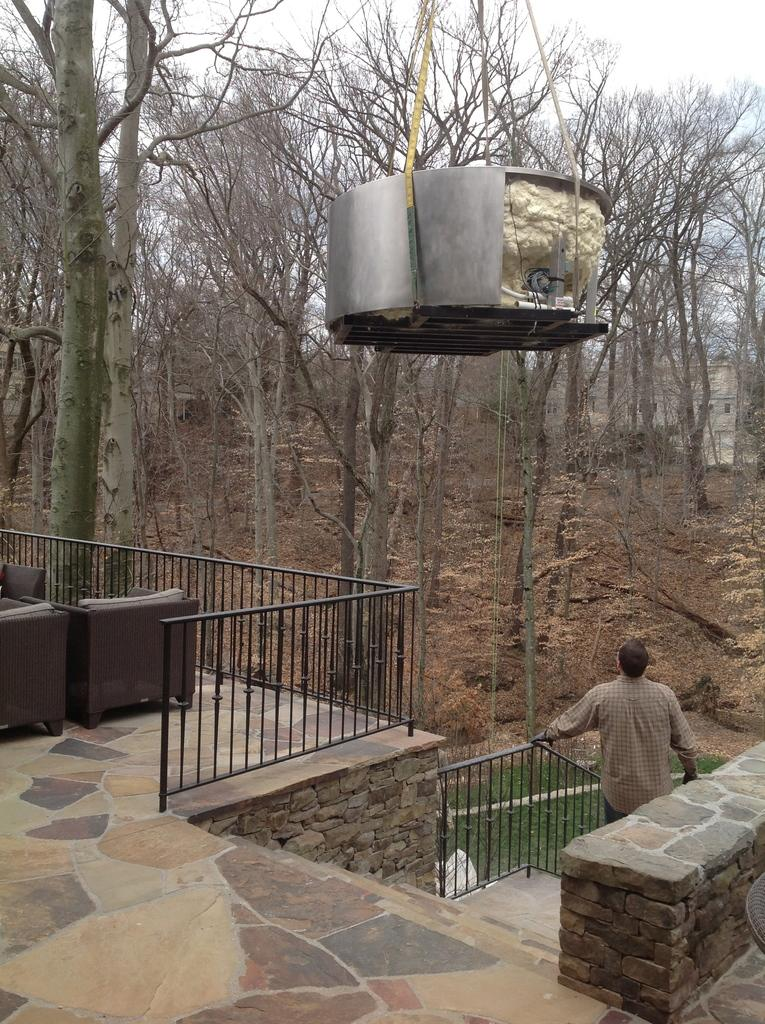What type of outdoor space is visible in the image? There is a balcony in the image. What feature is present on the balcony? The balcony has fencing. What furniture is on the balcony? There is a sofa set on the balcony. What can be seen in the background of the image? There are trees in the background of the image. What object is visible at the top of the image? There is a vessel visible at the top of the image. What type of clover is growing on the balcony in the image? There is no clover visible in the image; the balcony features a sofa set and fencing. 